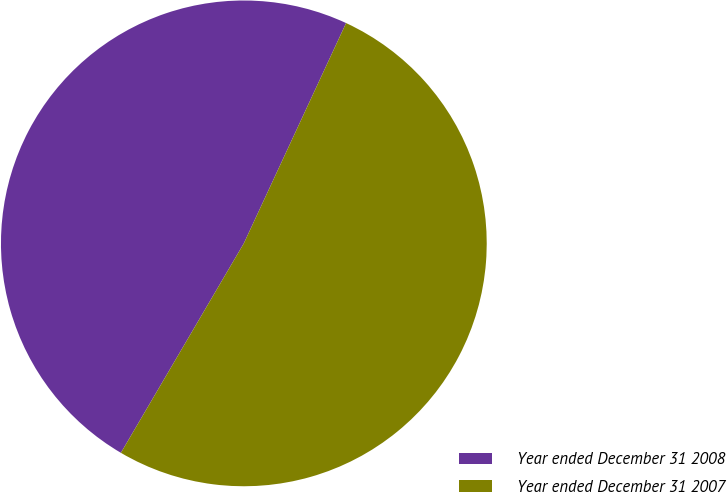<chart> <loc_0><loc_0><loc_500><loc_500><pie_chart><fcel>Year ended December 31 2008<fcel>Year ended December 31 2007<nl><fcel>48.47%<fcel>51.53%<nl></chart> 